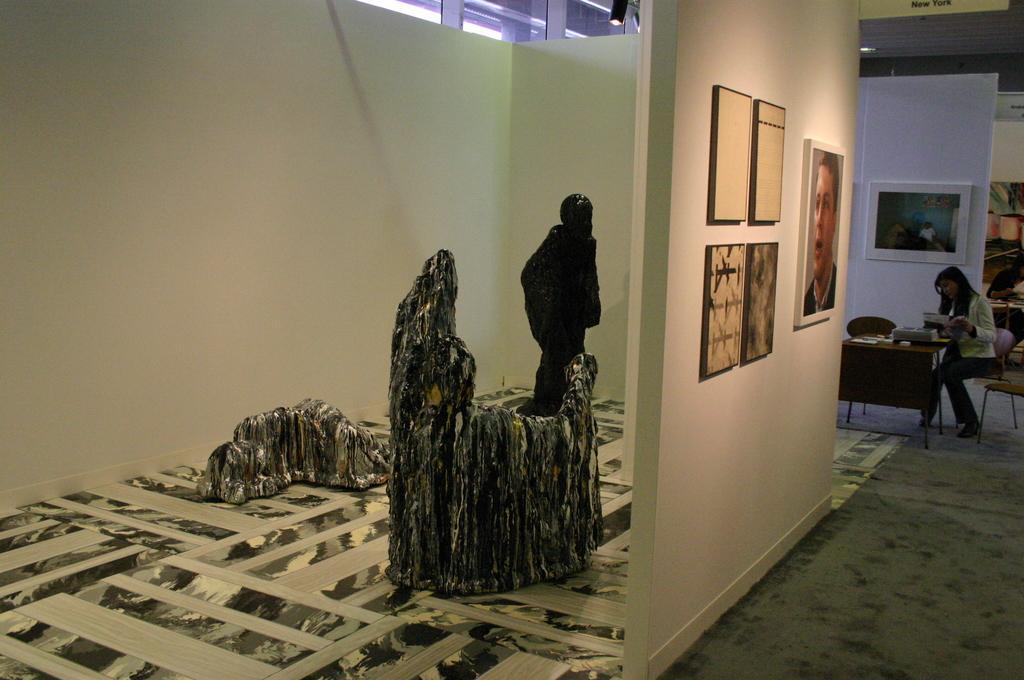In one or two sentences, can you explain what this image depicts? In this picture I can see rocks, there are two persons sitting on the chairs, there are some objects on the tables, there are frames attached to the wall. 